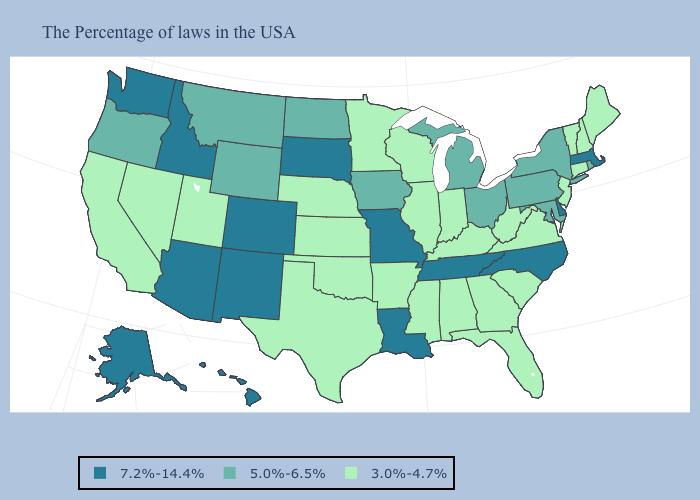Is the legend a continuous bar?
Give a very brief answer. No. What is the highest value in the USA?
Concise answer only. 7.2%-14.4%. Among the states that border New York , which have the highest value?
Be succinct. Massachusetts. Does California have the highest value in the West?
Keep it brief. No. Does Wisconsin have the highest value in the USA?
Short answer required. No. Does New Jersey have the lowest value in the USA?
Be succinct. Yes. Among the states that border Michigan , which have the lowest value?
Short answer required. Indiana, Wisconsin. Does the first symbol in the legend represent the smallest category?
Quick response, please. No. Does South Carolina have the same value as Iowa?
Quick response, please. No. What is the lowest value in the South?
Be succinct. 3.0%-4.7%. Does Georgia have a lower value than Arizona?
Short answer required. Yes. Does Arizona have the same value as Rhode Island?
Concise answer only. No. What is the lowest value in the MidWest?
Answer briefly. 3.0%-4.7%. What is the value of Wisconsin?
Give a very brief answer. 3.0%-4.7%. Name the states that have a value in the range 7.2%-14.4%?
Keep it brief. Massachusetts, Delaware, North Carolina, Tennessee, Louisiana, Missouri, South Dakota, Colorado, New Mexico, Arizona, Idaho, Washington, Alaska, Hawaii. 